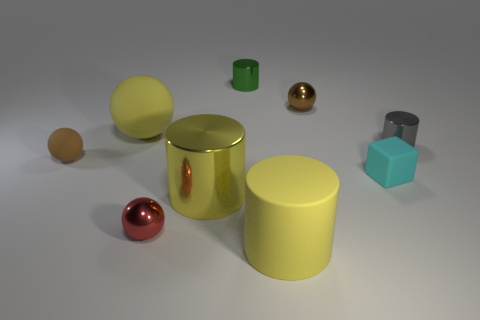Subtract 1 spheres. How many spheres are left? 3 Subtract all yellow cylinders. Subtract all blue blocks. How many cylinders are left? 2 Add 1 purple cubes. How many objects exist? 10 Subtract all cubes. How many objects are left? 8 Add 3 matte objects. How many matte objects exist? 7 Subtract 0 cyan cylinders. How many objects are left? 9 Subtract all brown objects. Subtract all blocks. How many objects are left? 6 Add 6 small cyan objects. How many small cyan objects are left? 7 